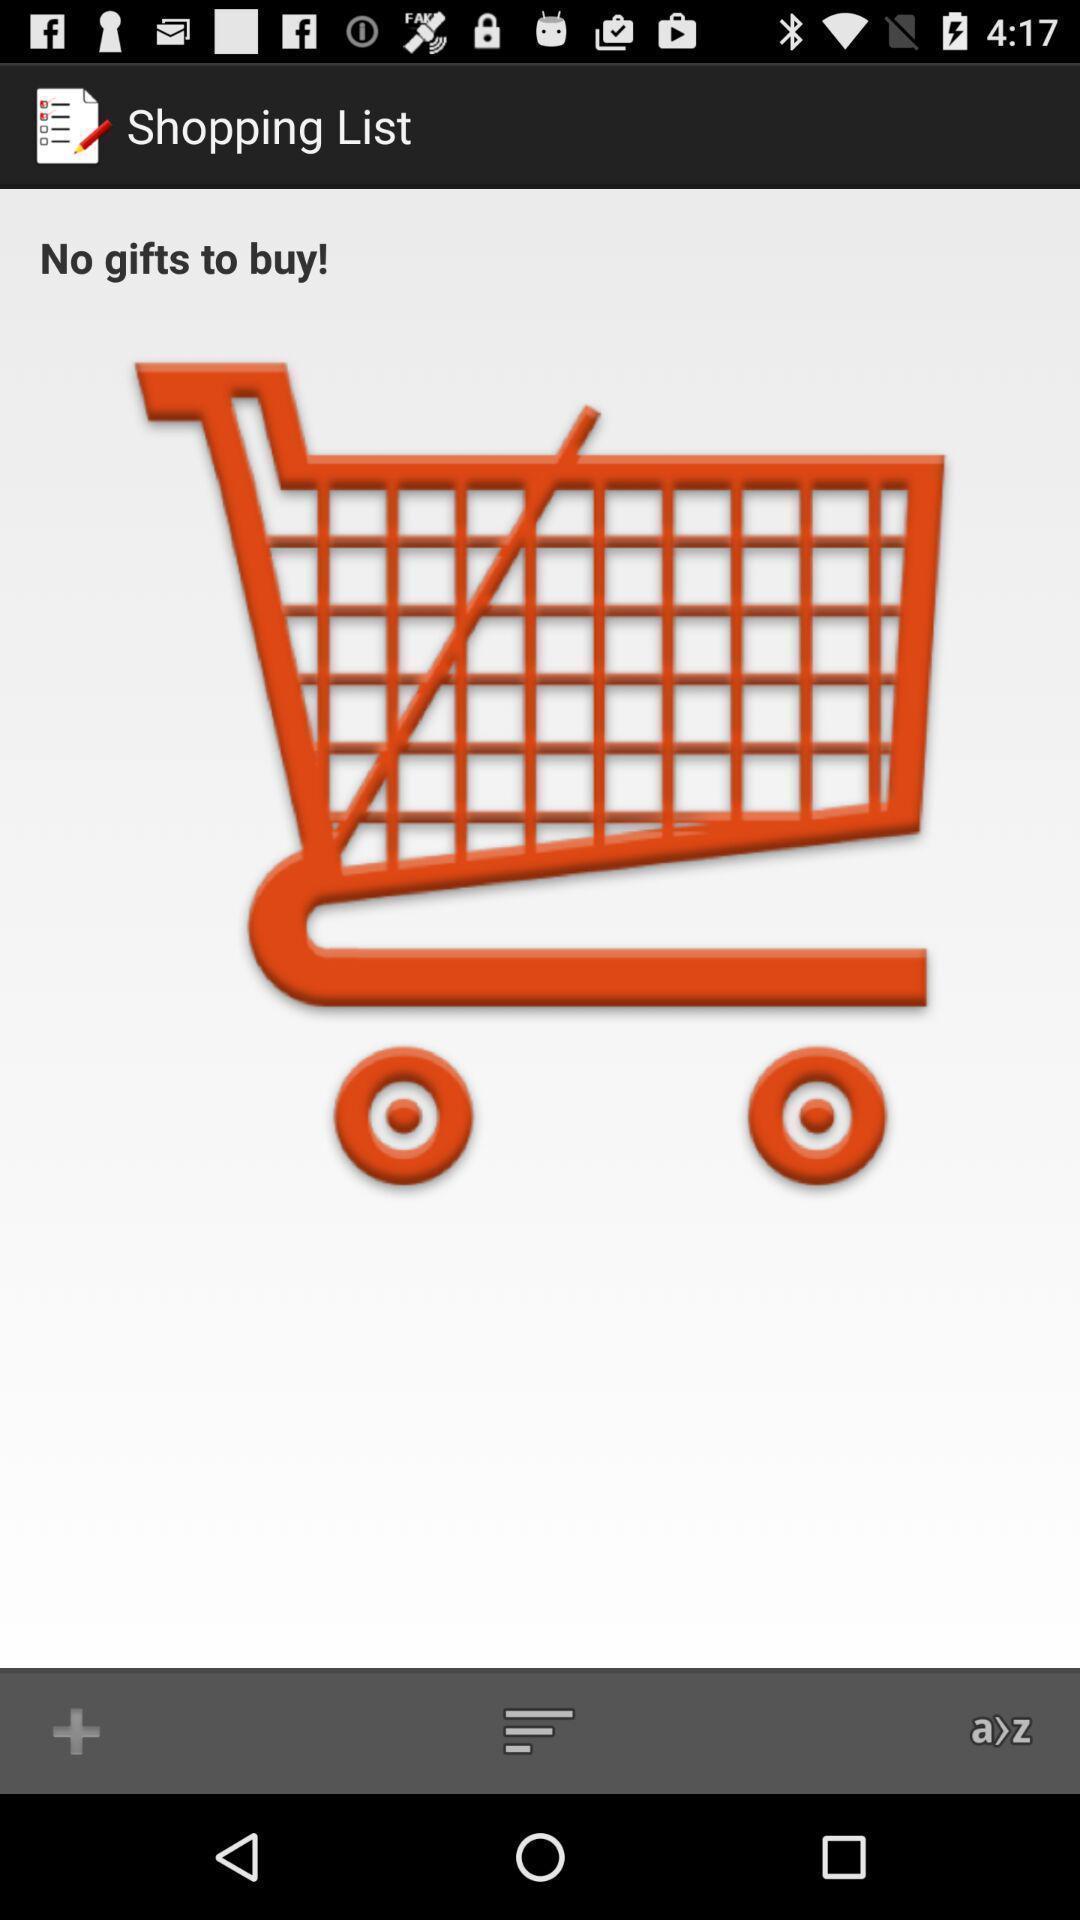Explain what's happening in this screen capture. Screen showing no gifts to buy in a shopping list. 